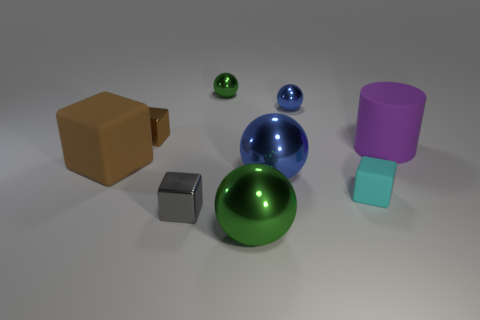There is a big brown thing that is the same shape as the small cyan thing; what is it made of?
Provide a succinct answer. Rubber. There is a small thing that is in front of the cylinder and behind the gray object; what is its shape?
Give a very brief answer. Cube. The small shiny thing in front of the tiny matte cube has what shape?
Your answer should be very brief. Cube. What number of tiny things are to the left of the tiny gray metallic cube and in front of the tiny cyan rubber block?
Ensure brevity in your answer.  0. Is the size of the purple cylinder the same as the matte block left of the big green metallic ball?
Give a very brief answer. Yes. There is a matte block that is left of the green metal sphere in front of the brown block that is behind the big cylinder; what size is it?
Provide a succinct answer. Large. What is the size of the green ball that is in front of the big purple thing?
Ensure brevity in your answer.  Large. What shape is the small brown thing that is made of the same material as the tiny blue ball?
Ensure brevity in your answer.  Cube. Are the tiny cube in front of the cyan rubber cube and the cyan cube made of the same material?
Keep it short and to the point. No. What number of other objects are there of the same material as the large blue object?
Your answer should be very brief. 5. 